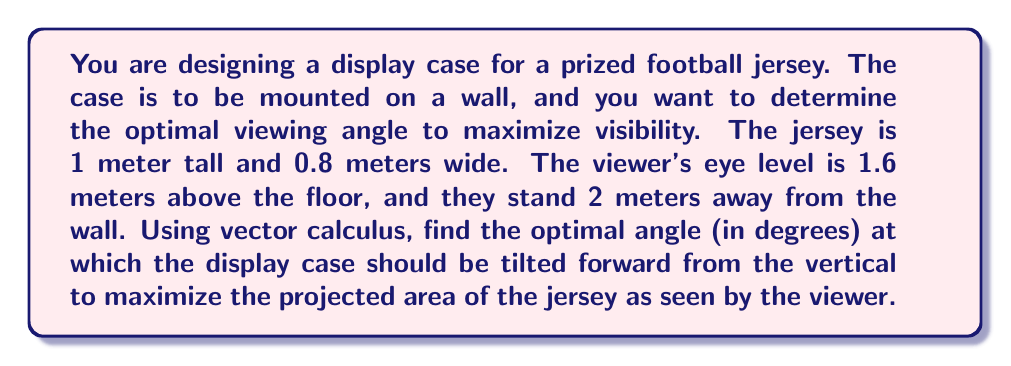Teach me how to tackle this problem. Let's approach this problem step by step using vector calculus:

1) First, we need to define our coordinate system. Let's set the origin at the bottom center of the jersey, with the x-axis pointing towards the viewer, the y-axis pointing up, and the z-axis pointing to the right.

2) The jersey can be represented as a rectangle in the yz-plane. The vector normal to this plane when not tilted is $\vec{n} = <1, 0, 0>$.

3) When we tilt the case by an angle $\theta$, the normal vector becomes:
   $$\vec{n}(\theta) = <\cos\theta, \sin\theta, 0>$$

4) The viewer's position vector is:
   $$\vec{v} = <2, 1.6, 0>$$

5) The projected area of the jersey is proportional to the dot product of the normal vector and the unit vector in the direction of the viewer's line of sight. We want to maximize this dot product.

6) The unit vector in the direction of the viewer's line of sight is:
   $$\vec{u} = \frac{\vec{v}}{|\vec{v}|} = \frac{<2, 1.6, 0>}{\sqrt{2^2 + 1.6^2}} = <0.781, 0.625, 0>$$

7) The dot product we want to maximize is:
   $$f(\theta) = \vec{n}(\theta) \cdot \vec{u} = 0.781\cos\theta + 0.625\sin\theta$$

8) To find the maximum, we differentiate and set to zero:
   $$\frac{df}{d\theta} = -0.781\sin\theta + 0.625\cos\theta = 0$$

9) Solving this equation:
   $$\tan\theta = \frac{0.625}{0.781} = 0.800$$

10) Taking the inverse tangent:
    $$\theta = \arctan(0.800) \approx 38.66^\circ$$

11) We can confirm this is a maximum by checking the second derivative is negative at this point.

[asy]
import geometry;

size(200);
defaultpen(fontsize(10pt));

pair O=(0,0), A=(2,0), B=(2,1.6);
draw(O--A--B--O);
draw(O--(-1,0),arrow=Arrow(TeXHead));
draw(O--(0,2),arrow=Arrow(TeXHead));
label("x", (-1,0), W);
label("y", (0,2), N);
label("Viewer", B, NE);
label("2m", (1,0), S);
label("1.6m", (2,0.8), E);

real theta = atan(0.8);
pair P = (cos(theta), sin(theta));
draw(O--P, arrow=Arrow(TeXHead), L=Label("$\vec{n}(\theta)$", position=0.5));
draw(arc(O,0.5,0,degrees(theta)), L=Label("$\theta$", position=0.5));

[/asy]
Answer: The optimal angle at which the display case should be tilted forward from the vertical is approximately $38.66^\circ$. 